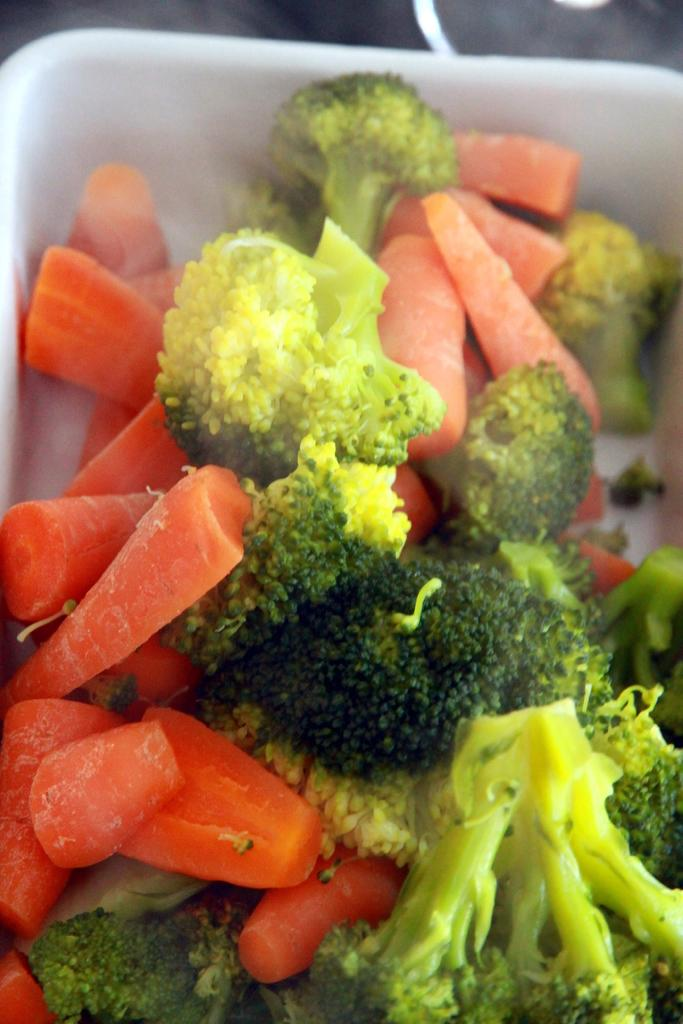What type of vegetables can be seen in the image? There are pieces of carrot and broccoli in the image. Where are these vegetables located? These pieces are in a bowl-like object. How many sisters can be seen climbing the hill in the image? There are no sisters or hills present in the image; it features pieces of carrot and broccoli in a bowl-like object. 